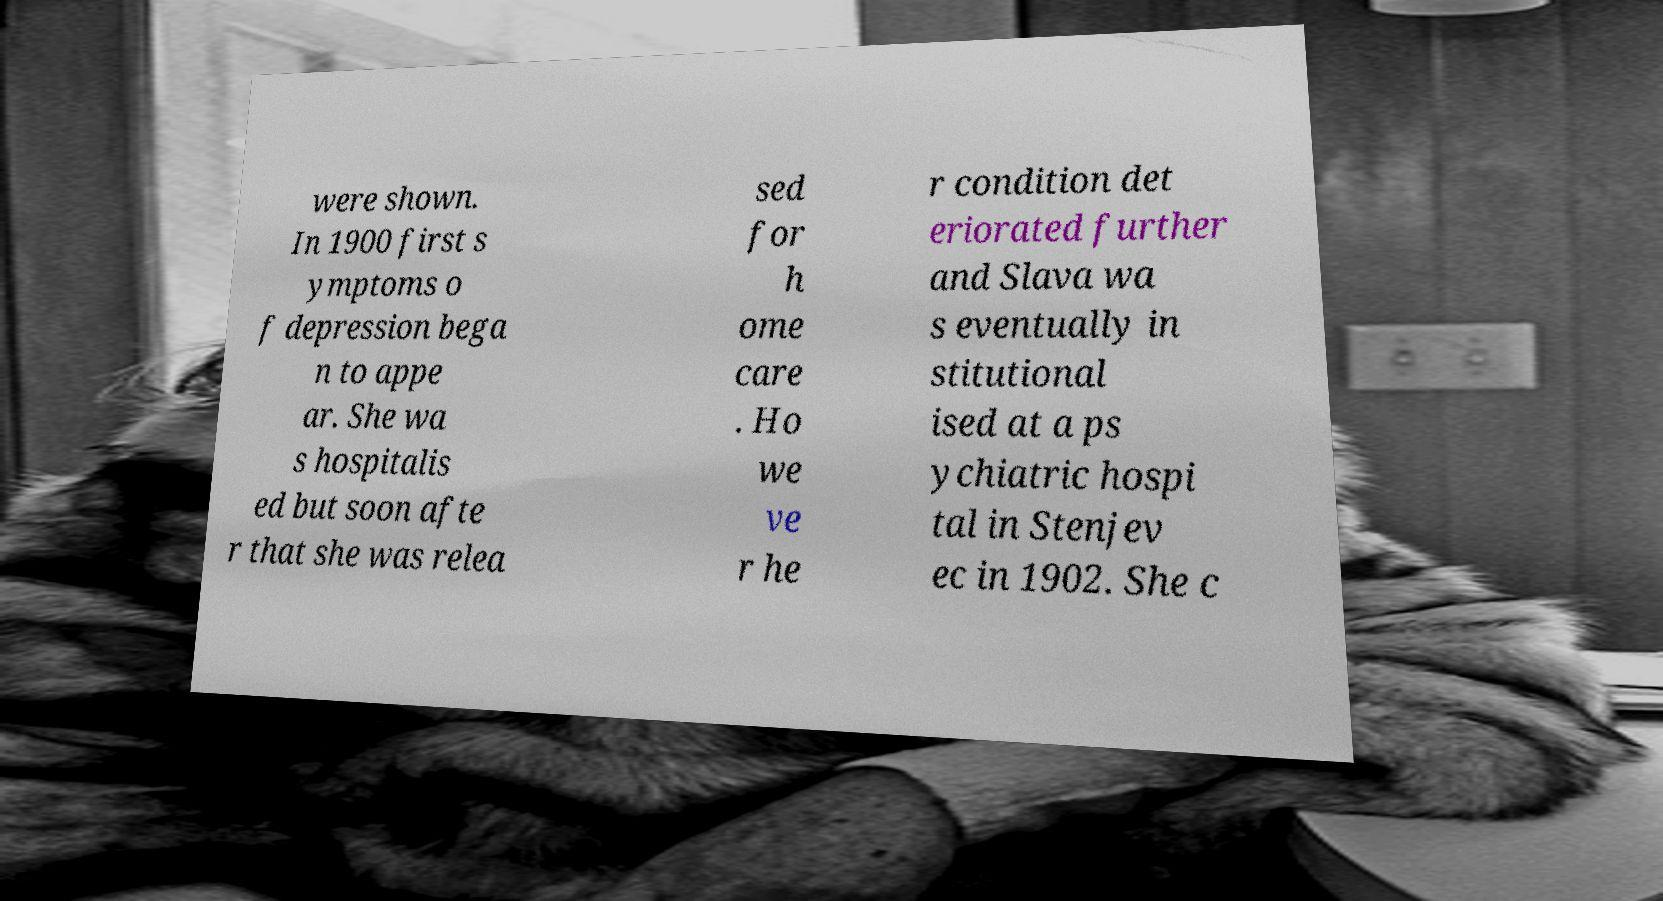Can you read and provide the text displayed in the image?This photo seems to have some interesting text. Can you extract and type it out for me? were shown. In 1900 first s ymptoms o f depression bega n to appe ar. She wa s hospitalis ed but soon afte r that she was relea sed for h ome care . Ho we ve r he r condition det eriorated further and Slava wa s eventually in stitutional ised at a ps ychiatric hospi tal in Stenjev ec in 1902. She c 